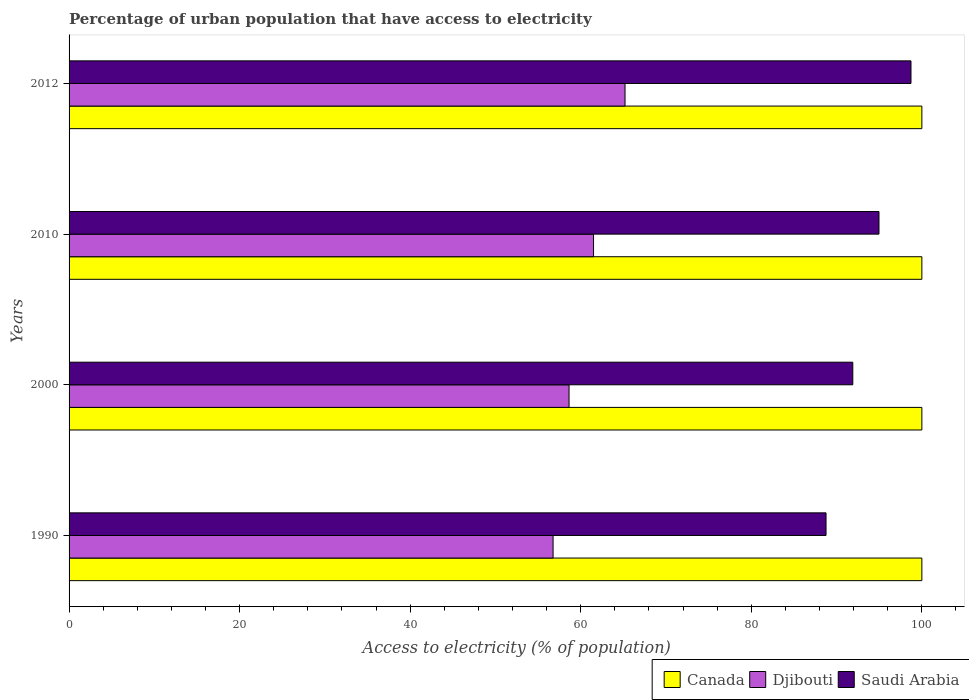How many different coloured bars are there?
Provide a short and direct response. 3. How many groups of bars are there?
Offer a terse response. 4. Are the number of bars per tick equal to the number of legend labels?
Offer a very short reply. Yes. Are the number of bars on each tick of the Y-axis equal?
Provide a succinct answer. Yes. How many bars are there on the 2nd tick from the bottom?
Your response must be concise. 3. What is the label of the 1st group of bars from the top?
Offer a terse response. 2012. What is the percentage of urban population that have access to electricity in Djibouti in 1990?
Your answer should be compact. 56.76. Across all years, what is the maximum percentage of urban population that have access to electricity in Canada?
Offer a very short reply. 100. Across all years, what is the minimum percentage of urban population that have access to electricity in Saudi Arabia?
Offer a terse response. 88.76. What is the total percentage of urban population that have access to electricity in Saudi Arabia in the graph?
Provide a short and direct response. 374.36. What is the difference between the percentage of urban population that have access to electricity in Saudi Arabia in 2010 and that in 2012?
Provide a short and direct response. -3.75. What is the difference between the percentage of urban population that have access to electricity in Djibouti in 1990 and the percentage of urban population that have access to electricity in Canada in 2000?
Give a very brief answer. -43.24. In the year 2000, what is the difference between the percentage of urban population that have access to electricity in Djibouti and percentage of urban population that have access to electricity in Saudi Arabia?
Offer a very short reply. -33.27. Is the percentage of urban population that have access to electricity in Saudi Arabia in 2000 less than that in 2012?
Give a very brief answer. Yes. Is the difference between the percentage of urban population that have access to electricity in Djibouti in 1990 and 2010 greater than the difference between the percentage of urban population that have access to electricity in Saudi Arabia in 1990 and 2010?
Your answer should be compact. Yes. What is the difference between the highest and the second highest percentage of urban population that have access to electricity in Saudi Arabia?
Your answer should be compact. 3.75. What is the difference between the highest and the lowest percentage of urban population that have access to electricity in Canada?
Make the answer very short. 0. In how many years, is the percentage of urban population that have access to electricity in Djibouti greater than the average percentage of urban population that have access to electricity in Djibouti taken over all years?
Provide a succinct answer. 2. Is the sum of the percentage of urban population that have access to electricity in Saudi Arabia in 1990 and 2000 greater than the maximum percentage of urban population that have access to electricity in Canada across all years?
Your response must be concise. Yes. What does the 2nd bar from the top in 2012 represents?
Your answer should be compact. Djibouti. How many years are there in the graph?
Offer a terse response. 4. What is the difference between two consecutive major ticks on the X-axis?
Ensure brevity in your answer.  20. Are the values on the major ticks of X-axis written in scientific E-notation?
Provide a succinct answer. No. Does the graph contain grids?
Offer a terse response. No. Where does the legend appear in the graph?
Your response must be concise. Bottom right. What is the title of the graph?
Your answer should be very brief. Percentage of urban population that have access to electricity. Does "New Caledonia" appear as one of the legend labels in the graph?
Provide a succinct answer. No. What is the label or title of the X-axis?
Give a very brief answer. Access to electricity (% of population). What is the Access to electricity (% of population) in Canada in 1990?
Keep it short and to the point. 100. What is the Access to electricity (% of population) of Djibouti in 1990?
Ensure brevity in your answer.  56.76. What is the Access to electricity (% of population) of Saudi Arabia in 1990?
Provide a short and direct response. 88.76. What is the Access to electricity (% of population) of Canada in 2000?
Your answer should be very brief. 100. What is the Access to electricity (% of population) in Djibouti in 2000?
Make the answer very short. 58.63. What is the Access to electricity (% of population) in Saudi Arabia in 2000?
Make the answer very short. 91.9. What is the Access to electricity (% of population) in Canada in 2010?
Your response must be concise. 100. What is the Access to electricity (% of population) in Djibouti in 2010?
Provide a short and direct response. 61.5. What is the Access to electricity (% of population) of Saudi Arabia in 2010?
Offer a terse response. 94.97. What is the Access to electricity (% of population) of Canada in 2012?
Your answer should be compact. 100. What is the Access to electricity (% of population) of Djibouti in 2012?
Make the answer very short. 65.19. What is the Access to electricity (% of population) in Saudi Arabia in 2012?
Keep it short and to the point. 98.73. Across all years, what is the maximum Access to electricity (% of population) of Canada?
Your response must be concise. 100. Across all years, what is the maximum Access to electricity (% of population) of Djibouti?
Make the answer very short. 65.19. Across all years, what is the maximum Access to electricity (% of population) in Saudi Arabia?
Offer a very short reply. 98.73. Across all years, what is the minimum Access to electricity (% of population) of Djibouti?
Your answer should be very brief. 56.76. Across all years, what is the minimum Access to electricity (% of population) in Saudi Arabia?
Offer a terse response. 88.76. What is the total Access to electricity (% of population) in Canada in the graph?
Give a very brief answer. 400. What is the total Access to electricity (% of population) of Djibouti in the graph?
Offer a very short reply. 242.08. What is the total Access to electricity (% of population) in Saudi Arabia in the graph?
Provide a short and direct response. 374.36. What is the difference between the Access to electricity (% of population) in Djibouti in 1990 and that in 2000?
Offer a terse response. -1.87. What is the difference between the Access to electricity (% of population) of Saudi Arabia in 1990 and that in 2000?
Keep it short and to the point. -3.14. What is the difference between the Access to electricity (% of population) of Canada in 1990 and that in 2010?
Keep it short and to the point. 0. What is the difference between the Access to electricity (% of population) of Djibouti in 1990 and that in 2010?
Make the answer very short. -4.74. What is the difference between the Access to electricity (% of population) in Saudi Arabia in 1990 and that in 2010?
Offer a terse response. -6.21. What is the difference between the Access to electricity (% of population) of Canada in 1990 and that in 2012?
Provide a short and direct response. 0. What is the difference between the Access to electricity (% of population) of Djibouti in 1990 and that in 2012?
Your answer should be compact. -8.44. What is the difference between the Access to electricity (% of population) of Saudi Arabia in 1990 and that in 2012?
Provide a succinct answer. -9.96. What is the difference between the Access to electricity (% of population) of Canada in 2000 and that in 2010?
Give a very brief answer. 0. What is the difference between the Access to electricity (% of population) of Djibouti in 2000 and that in 2010?
Ensure brevity in your answer.  -2.87. What is the difference between the Access to electricity (% of population) of Saudi Arabia in 2000 and that in 2010?
Ensure brevity in your answer.  -3.07. What is the difference between the Access to electricity (% of population) in Djibouti in 2000 and that in 2012?
Keep it short and to the point. -6.56. What is the difference between the Access to electricity (% of population) of Saudi Arabia in 2000 and that in 2012?
Keep it short and to the point. -6.82. What is the difference between the Access to electricity (% of population) in Canada in 2010 and that in 2012?
Provide a short and direct response. 0. What is the difference between the Access to electricity (% of population) in Djibouti in 2010 and that in 2012?
Your answer should be compact. -3.69. What is the difference between the Access to electricity (% of population) of Saudi Arabia in 2010 and that in 2012?
Your answer should be very brief. -3.75. What is the difference between the Access to electricity (% of population) of Canada in 1990 and the Access to electricity (% of population) of Djibouti in 2000?
Give a very brief answer. 41.37. What is the difference between the Access to electricity (% of population) in Canada in 1990 and the Access to electricity (% of population) in Saudi Arabia in 2000?
Ensure brevity in your answer.  8.1. What is the difference between the Access to electricity (% of population) in Djibouti in 1990 and the Access to electricity (% of population) in Saudi Arabia in 2000?
Your response must be concise. -35.15. What is the difference between the Access to electricity (% of population) in Canada in 1990 and the Access to electricity (% of population) in Djibouti in 2010?
Make the answer very short. 38.5. What is the difference between the Access to electricity (% of population) of Canada in 1990 and the Access to electricity (% of population) of Saudi Arabia in 2010?
Offer a terse response. 5.03. What is the difference between the Access to electricity (% of population) of Djibouti in 1990 and the Access to electricity (% of population) of Saudi Arabia in 2010?
Provide a succinct answer. -38.22. What is the difference between the Access to electricity (% of population) in Canada in 1990 and the Access to electricity (% of population) in Djibouti in 2012?
Give a very brief answer. 34.81. What is the difference between the Access to electricity (% of population) in Canada in 1990 and the Access to electricity (% of population) in Saudi Arabia in 2012?
Give a very brief answer. 1.27. What is the difference between the Access to electricity (% of population) of Djibouti in 1990 and the Access to electricity (% of population) of Saudi Arabia in 2012?
Your response must be concise. -41.97. What is the difference between the Access to electricity (% of population) of Canada in 2000 and the Access to electricity (% of population) of Djibouti in 2010?
Give a very brief answer. 38.5. What is the difference between the Access to electricity (% of population) in Canada in 2000 and the Access to electricity (% of population) in Saudi Arabia in 2010?
Your answer should be very brief. 5.03. What is the difference between the Access to electricity (% of population) of Djibouti in 2000 and the Access to electricity (% of population) of Saudi Arabia in 2010?
Your answer should be very brief. -36.34. What is the difference between the Access to electricity (% of population) in Canada in 2000 and the Access to electricity (% of population) in Djibouti in 2012?
Make the answer very short. 34.81. What is the difference between the Access to electricity (% of population) in Canada in 2000 and the Access to electricity (% of population) in Saudi Arabia in 2012?
Give a very brief answer. 1.27. What is the difference between the Access to electricity (% of population) in Djibouti in 2000 and the Access to electricity (% of population) in Saudi Arabia in 2012?
Give a very brief answer. -40.1. What is the difference between the Access to electricity (% of population) of Canada in 2010 and the Access to electricity (% of population) of Djibouti in 2012?
Provide a succinct answer. 34.81. What is the difference between the Access to electricity (% of population) of Canada in 2010 and the Access to electricity (% of population) of Saudi Arabia in 2012?
Keep it short and to the point. 1.27. What is the difference between the Access to electricity (% of population) in Djibouti in 2010 and the Access to electricity (% of population) in Saudi Arabia in 2012?
Your response must be concise. -37.23. What is the average Access to electricity (% of population) in Canada per year?
Make the answer very short. 100. What is the average Access to electricity (% of population) of Djibouti per year?
Make the answer very short. 60.52. What is the average Access to electricity (% of population) of Saudi Arabia per year?
Your answer should be compact. 93.59. In the year 1990, what is the difference between the Access to electricity (% of population) of Canada and Access to electricity (% of population) of Djibouti?
Offer a very short reply. 43.24. In the year 1990, what is the difference between the Access to electricity (% of population) of Canada and Access to electricity (% of population) of Saudi Arabia?
Make the answer very short. 11.24. In the year 1990, what is the difference between the Access to electricity (% of population) of Djibouti and Access to electricity (% of population) of Saudi Arabia?
Your answer should be compact. -32.01. In the year 2000, what is the difference between the Access to electricity (% of population) of Canada and Access to electricity (% of population) of Djibouti?
Keep it short and to the point. 41.37. In the year 2000, what is the difference between the Access to electricity (% of population) of Canada and Access to electricity (% of population) of Saudi Arabia?
Provide a short and direct response. 8.1. In the year 2000, what is the difference between the Access to electricity (% of population) of Djibouti and Access to electricity (% of population) of Saudi Arabia?
Provide a succinct answer. -33.27. In the year 2010, what is the difference between the Access to electricity (% of population) of Canada and Access to electricity (% of population) of Djibouti?
Your answer should be compact. 38.5. In the year 2010, what is the difference between the Access to electricity (% of population) of Canada and Access to electricity (% of population) of Saudi Arabia?
Make the answer very short. 5.03. In the year 2010, what is the difference between the Access to electricity (% of population) of Djibouti and Access to electricity (% of population) of Saudi Arabia?
Give a very brief answer. -33.47. In the year 2012, what is the difference between the Access to electricity (% of population) of Canada and Access to electricity (% of population) of Djibouti?
Give a very brief answer. 34.81. In the year 2012, what is the difference between the Access to electricity (% of population) of Canada and Access to electricity (% of population) of Saudi Arabia?
Keep it short and to the point. 1.27. In the year 2012, what is the difference between the Access to electricity (% of population) in Djibouti and Access to electricity (% of population) in Saudi Arabia?
Make the answer very short. -33.53. What is the ratio of the Access to electricity (% of population) of Djibouti in 1990 to that in 2000?
Ensure brevity in your answer.  0.97. What is the ratio of the Access to electricity (% of population) in Saudi Arabia in 1990 to that in 2000?
Provide a short and direct response. 0.97. What is the ratio of the Access to electricity (% of population) of Djibouti in 1990 to that in 2010?
Your answer should be very brief. 0.92. What is the ratio of the Access to electricity (% of population) of Saudi Arabia in 1990 to that in 2010?
Your response must be concise. 0.93. What is the ratio of the Access to electricity (% of population) in Canada in 1990 to that in 2012?
Keep it short and to the point. 1. What is the ratio of the Access to electricity (% of population) of Djibouti in 1990 to that in 2012?
Provide a short and direct response. 0.87. What is the ratio of the Access to electricity (% of population) in Saudi Arabia in 1990 to that in 2012?
Ensure brevity in your answer.  0.9. What is the ratio of the Access to electricity (% of population) of Djibouti in 2000 to that in 2010?
Give a very brief answer. 0.95. What is the ratio of the Access to electricity (% of population) of Saudi Arabia in 2000 to that in 2010?
Provide a short and direct response. 0.97. What is the ratio of the Access to electricity (% of population) of Canada in 2000 to that in 2012?
Give a very brief answer. 1. What is the ratio of the Access to electricity (% of population) of Djibouti in 2000 to that in 2012?
Keep it short and to the point. 0.9. What is the ratio of the Access to electricity (% of population) in Saudi Arabia in 2000 to that in 2012?
Keep it short and to the point. 0.93. What is the ratio of the Access to electricity (% of population) in Canada in 2010 to that in 2012?
Offer a terse response. 1. What is the ratio of the Access to electricity (% of population) of Djibouti in 2010 to that in 2012?
Ensure brevity in your answer.  0.94. What is the ratio of the Access to electricity (% of population) in Saudi Arabia in 2010 to that in 2012?
Provide a short and direct response. 0.96. What is the difference between the highest and the second highest Access to electricity (% of population) of Canada?
Ensure brevity in your answer.  0. What is the difference between the highest and the second highest Access to electricity (% of population) of Djibouti?
Make the answer very short. 3.69. What is the difference between the highest and the second highest Access to electricity (% of population) of Saudi Arabia?
Provide a short and direct response. 3.75. What is the difference between the highest and the lowest Access to electricity (% of population) in Canada?
Your response must be concise. 0. What is the difference between the highest and the lowest Access to electricity (% of population) of Djibouti?
Your response must be concise. 8.44. What is the difference between the highest and the lowest Access to electricity (% of population) of Saudi Arabia?
Provide a succinct answer. 9.96. 